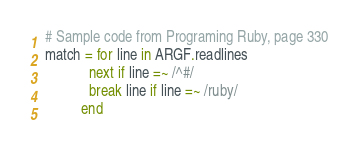Convert code to text. <code><loc_0><loc_0><loc_500><loc_500><_Ruby_># Sample code from Programing Ruby, page 330
match = for line in ARGF.readlines
            next if line =~ /^#/
            break line if line =~ /ruby/
          end
</code> 